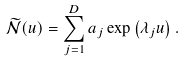<formula> <loc_0><loc_0><loc_500><loc_500>\widetilde { \mathcal { N } } ( u ) = \sum _ { j = 1 } ^ { D } a _ { j } \exp \left ( \lambda _ { j } u \right ) .</formula> 